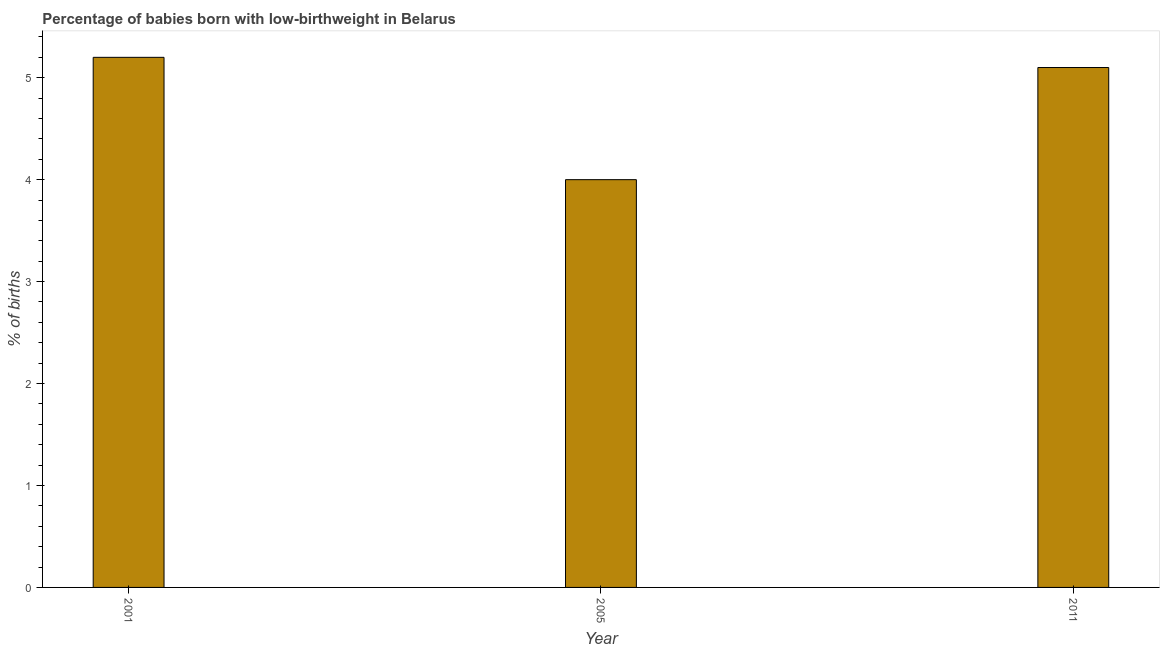Does the graph contain any zero values?
Ensure brevity in your answer.  No. Does the graph contain grids?
Your answer should be very brief. No. What is the title of the graph?
Your answer should be compact. Percentage of babies born with low-birthweight in Belarus. What is the label or title of the Y-axis?
Provide a succinct answer. % of births. What is the percentage of babies who were born with low-birthweight in 2011?
Give a very brief answer. 5.1. Across all years, what is the maximum percentage of babies who were born with low-birthweight?
Your answer should be very brief. 5.2. In which year was the percentage of babies who were born with low-birthweight maximum?
Provide a succinct answer. 2001. In which year was the percentage of babies who were born with low-birthweight minimum?
Offer a very short reply. 2005. What is the sum of the percentage of babies who were born with low-birthweight?
Provide a short and direct response. 14.3. What is the average percentage of babies who were born with low-birthweight per year?
Your answer should be very brief. 4.77. What is the median percentage of babies who were born with low-birthweight?
Offer a terse response. 5.1. In how many years, is the percentage of babies who were born with low-birthweight greater than 1.8 %?
Make the answer very short. 3. Do a majority of the years between 2011 and 2005 (inclusive) have percentage of babies who were born with low-birthweight greater than 5.2 %?
Ensure brevity in your answer.  No. What is the ratio of the percentage of babies who were born with low-birthweight in 2001 to that in 2011?
Your response must be concise. 1.02. Is the percentage of babies who were born with low-birthweight in 2005 less than that in 2011?
Provide a short and direct response. Yes. Is the difference between the percentage of babies who were born with low-birthweight in 2005 and 2011 greater than the difference between any two years?
Offer a terse response. No. What is the difference between the highest and the lowest percentage of babies who were born with low-birthweight?
Provide a short and direct response. 1.2. How many bars are there?
Make the answer very short. 3. Are all the bars in the graph horizontal?
Keep it short and to the point. No. How many years are there in the graph?
Your answer should be compact. 3. What is the difference between two consecutive major ticks on the Y-axis?
Your answer should be very brief. 1. What is the % of births of 2005?
Ensure brevity in your answer.  4. What is the difference between the % of births in 2001 and 2005?
Offer a very short reply. 1.2. What is the difference between the % of births in 2005 and 2011?
Make the answer very short. -1.1. What is the ratio of the % of births in 2005 to that in 2011?
Your answer should be very brief. 0.78. 